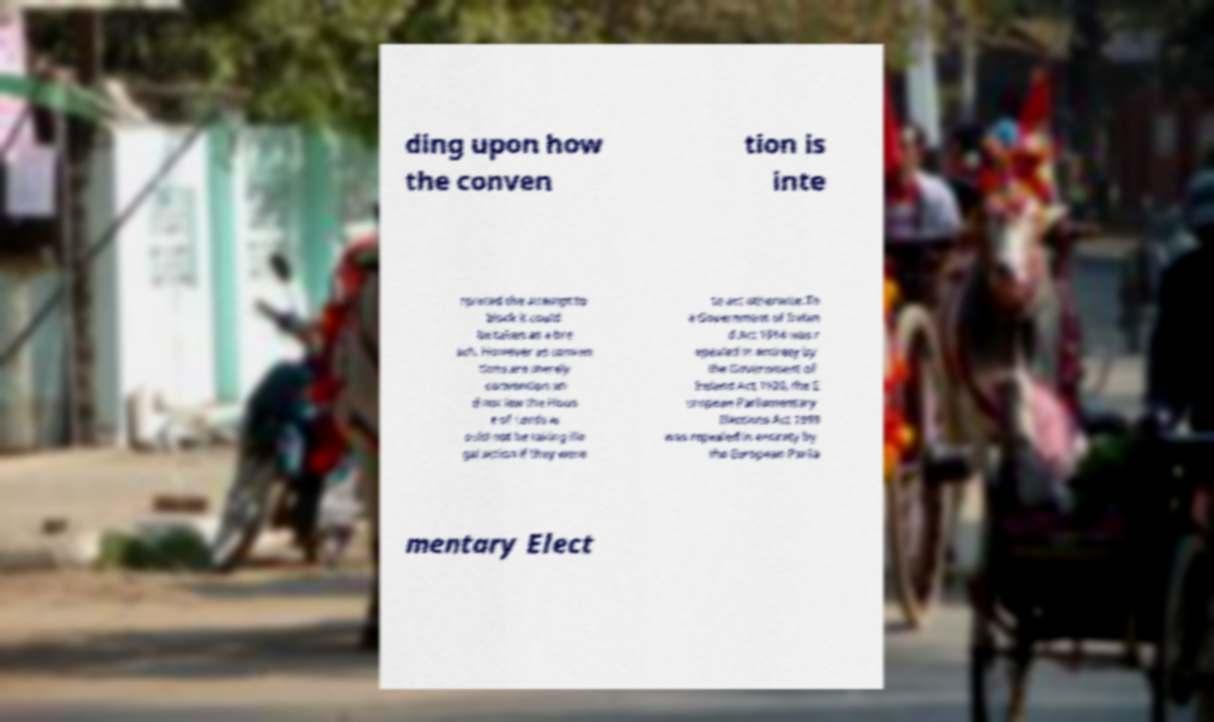Can you read and provide the text displayed in the image?This photo seems to have some interesting text. Can you extract and type it out for me? ding upon how the conven tion is inte rpreted the attempt to block it could be taken as a bre ach. However as conven tions are merely convention an d not law the Hous e of Lords w ould not be taking ille gal action if they were to act otherwise.Th e Government of Irelan d Act 1914 was r epealed in entirety by the Government of Ireland Act 1920, the E uropean Parliamentary Elections Act 1999 was repealed in entirety by the European Parlia mentary Elect 